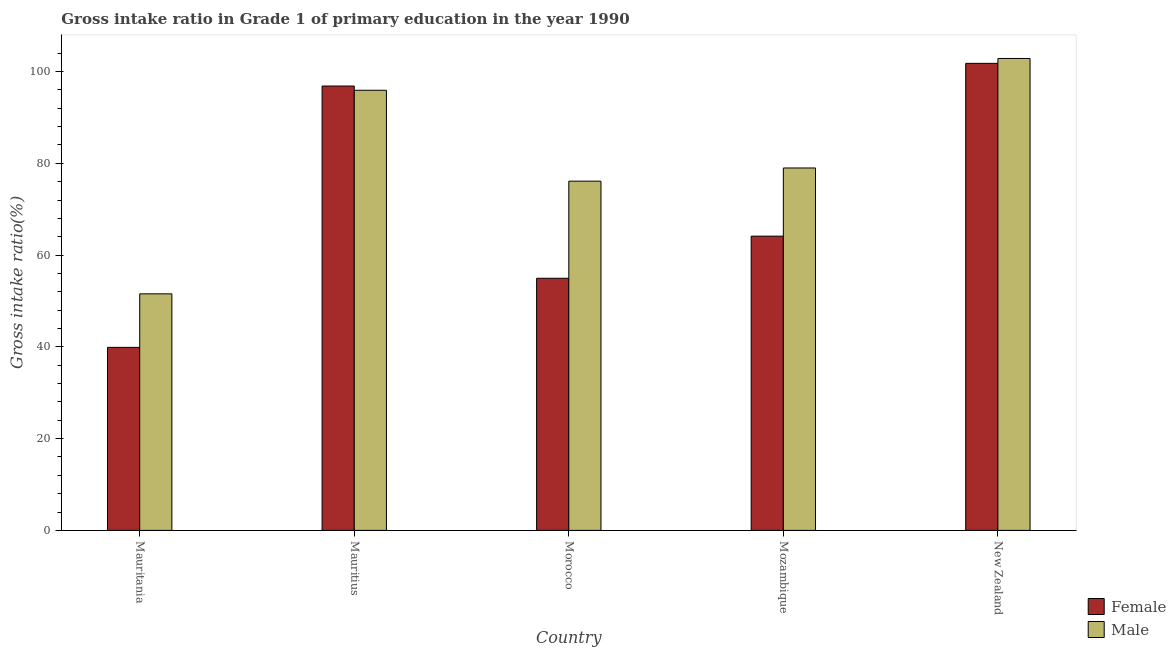How many groups of bars are there?
Provide a short and direct response. 5. Are the number of bars per tick equal to the number of legend labels?
Offer a very short reply. Yes. Are the number of bars on each tick of the X-axis equal?
Your answer should be compact. Yes. What is the label of the 3rd group of bars from the left?
Provide a succinct answer. Morocco. In how many cases, is the number of bars for a given country not equal to the number of legend labels?
Offer a very short reply. 0. What is the gross intake ratio(female) in New Zealand?
Provide a succinct answer. 101.79. Across all countries, what is the maximum gross intake ratio(male)?
Make the answer very short. 102.85. Across all countries, what is the minimum gross intake ratio(male)?
Your answer should be very brief. 51.55. In which country was the gross intake ratio(male) maximum?
Your response must be concise. New Zealand. In which country was the gross intake ratio(female) minimum?
Make the answer very short. Mauritania. What is the total gross intake ratio(female) in the graph?
Your response must be concise. 357.59. What is the difference between the gross intake ratio(male) in Morocco and that in New Zealand?
Provide a short and direct response. -26.74. What is the difference between the gross intake ratio(male) in New Zealand and the gross intake ratio(female) in Morocco?
Offer a very short reply. 47.9. What is the average gross intake ratio(female) per country?
Your answer should be compact. 71.52. What is the difference between the gross intake ratio(female) and gross intake ratio(male) in Morocco?
Provide a succinct answer. -21.16. In how many countries, is the gross intake ratio(female) greater than 64 %?
Your response must be concise. 3. What is the ratio of the gross intake ratio(male) in Mauritius to that in Mozambique?
Keep it short and to the point. 1.21. What is the difference between the highest and the second highest gross intake ratio(female)?
Your response must be concise. 4.94. What is the difference between the highest and the lowest gross intake ratio(female)?
Offer a terse response. 61.9. How many bars are there?
Provide a short and direct response. 10. How many countries are there in the graph?
Give a very brief answer. 5. What is the difference between two consecutive major ticks on the Y-axis?
Offer a very short reply. 20. Are the values on the major ticks of Y-axis written in scientific E-notation?
Ensure brevity in your answer.  No. Does the graph contain any zero values?
Offer a very short reply. No. Does the graph contain grids?
Offer a very short reply. No. How many legend labels are there?
Offer a terse response. 2. What is the title of the graph?
Your answer should be compact. Gross intake ratio in Grade 1 of primary education in the year 1990. What is the label or title of the Y-axis?
Provide a short and direct response. Gross intake ratio(%). What is the Gross intake ratio(%) in Female in Mauritania?
Your answer should be compact. 39.89. What is the Gross intake ratio(%) in Male in Mauritania?
Offer a very short reply. 51.55. What is the Gross intake ratio(%) of Female in Mauritius?
Make the answer very short. 96.84. What is the Gross intake ratio(%) of Male in Mauritius?
Your response must be concise. 95.92. What is the Gross intake ratio(%) of Female in Morocco?
Give a very brief answer. 54.95. What is the Gross intake ratio(%) of Male in Morocco?
Give a very brief answer. 76.11. What is the Gross intake ratio(%) in Female in Mozambique?
Offer a very short reply. 64.13. What is the Gross intake ratio(%) of Male in Mozambique?
Give a very brief answer. 78.98. What is the Gross intake ratio(%) in Female in New Zealand?
Offer a terse response. 101.79. What is the Gross intake ratio(%) of Male in New Zealand?
Make the answer very short. 102.85. Across all countries, what is the maximum Gross intake ratio(%) in Female?
Provide a succinct answer. 101.79. Across all countries, what is the maximum Gross intake ratio(%) of Male?
Keep it short and to the point. 102.85. Across all countries, what is the minimum Gross intake ratio(%) of Female?
Offer a very short reply. 39.89. Across all countries, what is the minimum Gross intake ratio(%) in Male?
Keep it short and to the point. 51.55. What is the total Gross intake ratio(%) of Female in the graph?
Ensure brevity in your answer.  357.59. What is the total Gross intake ratio(%) in Male in the graph?
Offer a terse response. 405.41. What is the difference between the Gross intake ratio(%) of Female in Mauritania and that in Mauritius?
Keep it short and to the point. -56.96. What is the difference between the Gross intake ratio(%) in Male in Mauritania and that in Mauritius?
Provide a succinct answer. -44.36. What is the difference between the Gross intake ratio(%) in Female in Mauritania and that in Morocco?
Offer a very short reply. -15.06. What is the difference between the Gross intake ratio(%) in Male in Mauritania and that in Morocco?
Give a very brief answer. -24.55. What is the difference between the Gross intake ratio(%) in Female in Mauritania and that in Mozambique?
Provide a succinct answer. -24.24. What is the difference between the Gross intake ratio(%) in Male in Mauritania and that in Mozambique?
Give a very brief answer. -27.43. What is the difference between the Gross intake ratio(%) of Female in Mauritania and that in New Zealand?
Keep it short and to the point. -61.9. What is the difference between the Gross intake ratio(%) in Male in Mauritania and that in New Zealand?
Offer a terse response. -51.29. What is the difference between the Gross intake ratio(%) of Female in Mauritius and that in Morocco?
Ensure brevity in your answer.  41.9. What is the difference between the Gross intake ratio(%) of Male in Mauritius and that in Morocco?
Offer a terse response. 19.81. What is the difference between the Gross intake ratio(%) of Female in Mauritius and that in Mozambique?
Ensure brevity in your answer.  32.72. What is the difference between the Gross intake ratio(%) in Male in Mauritius and that in Mozambique?
Make the answer very short. 16.93. What is the difference between the Gross intake ratio(%) of Female in Mauritius and that in New Zealand?
Provide a short and direct response. -4.94. What is the difference between the Gross intake ratio(%) in Male in Mauritius and that in New Zealand?
Provide a short and direct response. -6.93. What is the difference between the Gross intake ratio(%) of Female in Morocco and that in Mozambique?
Offer a very short reply. -9.18. What is the difference between the Gross intake ratio(%) of Male in Morocco and that in Mozambique?
Offer a very short reply. -2.88. What is the difference between the Gross intake ratio(%) of Female in Morocco and that in New Zealand?
Offer a terse response. -46.84. What is the difference between the Gross intake ratio(%) in Male in Morocco and that in New Zealand?
Keep it short and to the point. -26.74. What is the difference between the Gross intake ratio(%) of Female in Mozambique and that in New Zealand?
Give a very brief answer. -37.66. What is the difference between the Gross intake ratio(%) in Male in Mozambique and that in New Zealand?
Offer a terse response. -23.86. What is the difference between the Gross intake ratio(%) in Female in Mauritania and the Gross intake ratio(%) in Male in Mauritius?
Your answer should be compact. -56.03. What is the difference between the Gross intake ratio(%) in Female in Mauritania and the Gross intake ratio(%) in Male in Morocco?
Give a very brief answer. -36.22. What is the difference between the Gross intake ratio(%) in Female in Mauritania and the Gross intake ratio(%) in Male in Mozambique?
Offer a terse response. -39.1. What is the difference between the Gross intake ratio(%) of Female in Mauritania and the Gross intake ratio(%) of Male in New Zealand?
Offer a very short reply. -62.96. What is the difference between the Gross intake ratio(%) of Female in Mauritius and the Gross intake ratio(%) of Male in Morocco?
Provide a succinct answer. 20.74. What is the difference between the Gross intake ratio(%) in Female in Mauritius and the Gross intake ratio(%) in Male in Mozambique?
Give a very brief answer. 17.86. What is the difference between the Gross intake ratio(%) of Female in Mauritius and the Gross intake ratio(%) of Male in New Zealand?
Give a very brief answer. -6. What is the difference between the Gross intake ratio(%) of Female in Morocco and the Gross intake ratio(%) of Male in Mozambique?
Ensure brevity in your answer.  -24.04. What is the difference between the Gross intake ratio(%) in Female in Morocco and the Gross intake ratio(%) in Male in New Zealand?
Offer a terse response. -47.9. What is the difference between the Gross intake ratio(%) of Female in Mozambique and the Gross intake ratio(%) of Male in New Zealand?
Keep it short and to the point. -38.72. What is the average Gross intake ratio(%) in Female per country?
Make the answer very short. 71.52. What is the average Gross intake ratio(%) of Male per country?
Your answer should be very brief. 81.08. What is the difference between the Gross intake ratio(%) of Female and Gross intake ratio(%) of Male in Mauritania?
Keep it short and to the point. -11.67. What is the difference between the Gross intake ratio(%) in Female and Gross intake ratio(%) in Male in Mauritius?
Offer a terse response. 0.93. What is the difference between the Gross intake ratio(%) of Female and Gross intake ratio(%) of Male in Morocco?
Offer a very short reply. -21.16. What is the difference between the Gross intake ratio(%) of Female and Gross intake ratio(%) of Male in Mozambique?
Provide a short and direct response. -14.86. What is the difference between the Gross intake ratio(%) of Female and Gross intake ratio(%) of Male in New Zealand?
Make the answer very short. -1.06. What is the ratio of the Gross intake ratio(%) in Female in Mauritania to that in Mauritius?
Your answer should be very brief. 0.41. What is the ratio of the Gross intake ratio(%) of Male in Mauritania to that in Mauritius?
Ensure brevity in your answer.  0.54. What is the ratio of the Gross intake ratio(%) of Female in Mauritania to that in Morocco?
Your answer should be very brief. 0.73. What is the ratio of the Gross intake ratio(%) of Male in Mauritania to that in Morocco?
Ensure brevity in your answer.  0.68. What is the ratio of the Gross intake ratio(%) of Female in Mauritania to that in Mozambique?
Offer a very short reply. 0.62. What is the ratio of the Gross intake ratio(%) in Male in Mauritania to that in Mozambique?
Provide a short and direct response. 0.65. What is the ratio of the Gross intake ratio(%) in Female in Mauritania to that in New Zealand?
Your answer should be very brief. 0.39. What is the ratio of the Gross intake ratio(%) of Male in Mauritania to that in New Zealand?
Provide a short and direct response. 0.5. What is the ratio of the Gross intake ratio(%) of Female in Mauritius to that in Morocco?
Ensure brevity in your answer.  1.76. What is the ratio of the Gross intake ratio(%) of Male in Mauritius to that in Morocco?
Your response must be concise. 1.26. What is the ratio of the Gross intake ratio(%) in Female in Mauritius to that in Mozambique?
Your response must be concise. 1.51. What is the ratio of the Gross intake ratio(%) of Male in Mauritius to that in Mozambique?
Ensure brevity in your answer.  1.21. What is the ratio of the Gross intake ratio(%) of Female in Mauritius to that in New Zealand?
Your response must be concise. 0.95. What is the ratio of the Gross intake ratio(%) in Male in Mauritius to that in New Zealand?
Make the answer very short. 0.93. What is the ratio of the Gross intake ratio(%) of Female in Morocco to that in Mozambique?
Keep it short and to the point. 0.86. What is the ratio of the Gross intake ratio(%) of Male in Morocco to that in Mozambique?
Provide a short and direct response. 0.96. What is the ratio of the Gross intake ratio(%) of Female in Morocco to that in New Zealand?
Your answer should be compact. 0.54. What is the ratio of the Gross intake ratio(%) in Male in Morocco to that in New Zealand?
Make the answer very short. 0.74. What is the ratio of the Gross intake ratio(%) in Female in Mozambique to that in New Zealand?
Provide a succinct answer. 0.63. What is the ratio of the Gross intake ratio(%) of Male in Mozambique to that in New Zealand?
Ensure brevity in your answer.  0.77. What is the difference between the highest and the second highest Gross intake ratio(%) of Female?
Your answer should be very brief. 4.94. What is the difference between the highest and the second highest Gross intake ratio(%) in Male?
Your response must be concise. 6.93. What is the difference between the highest and the lowest Gross intake ratio(%) of Female?
Ensure brevity in your answer.  61.9. What is the difference between the highest and the lowest Gross intake ratio(%) of Male?
Give a very brief answer. 51.29. 